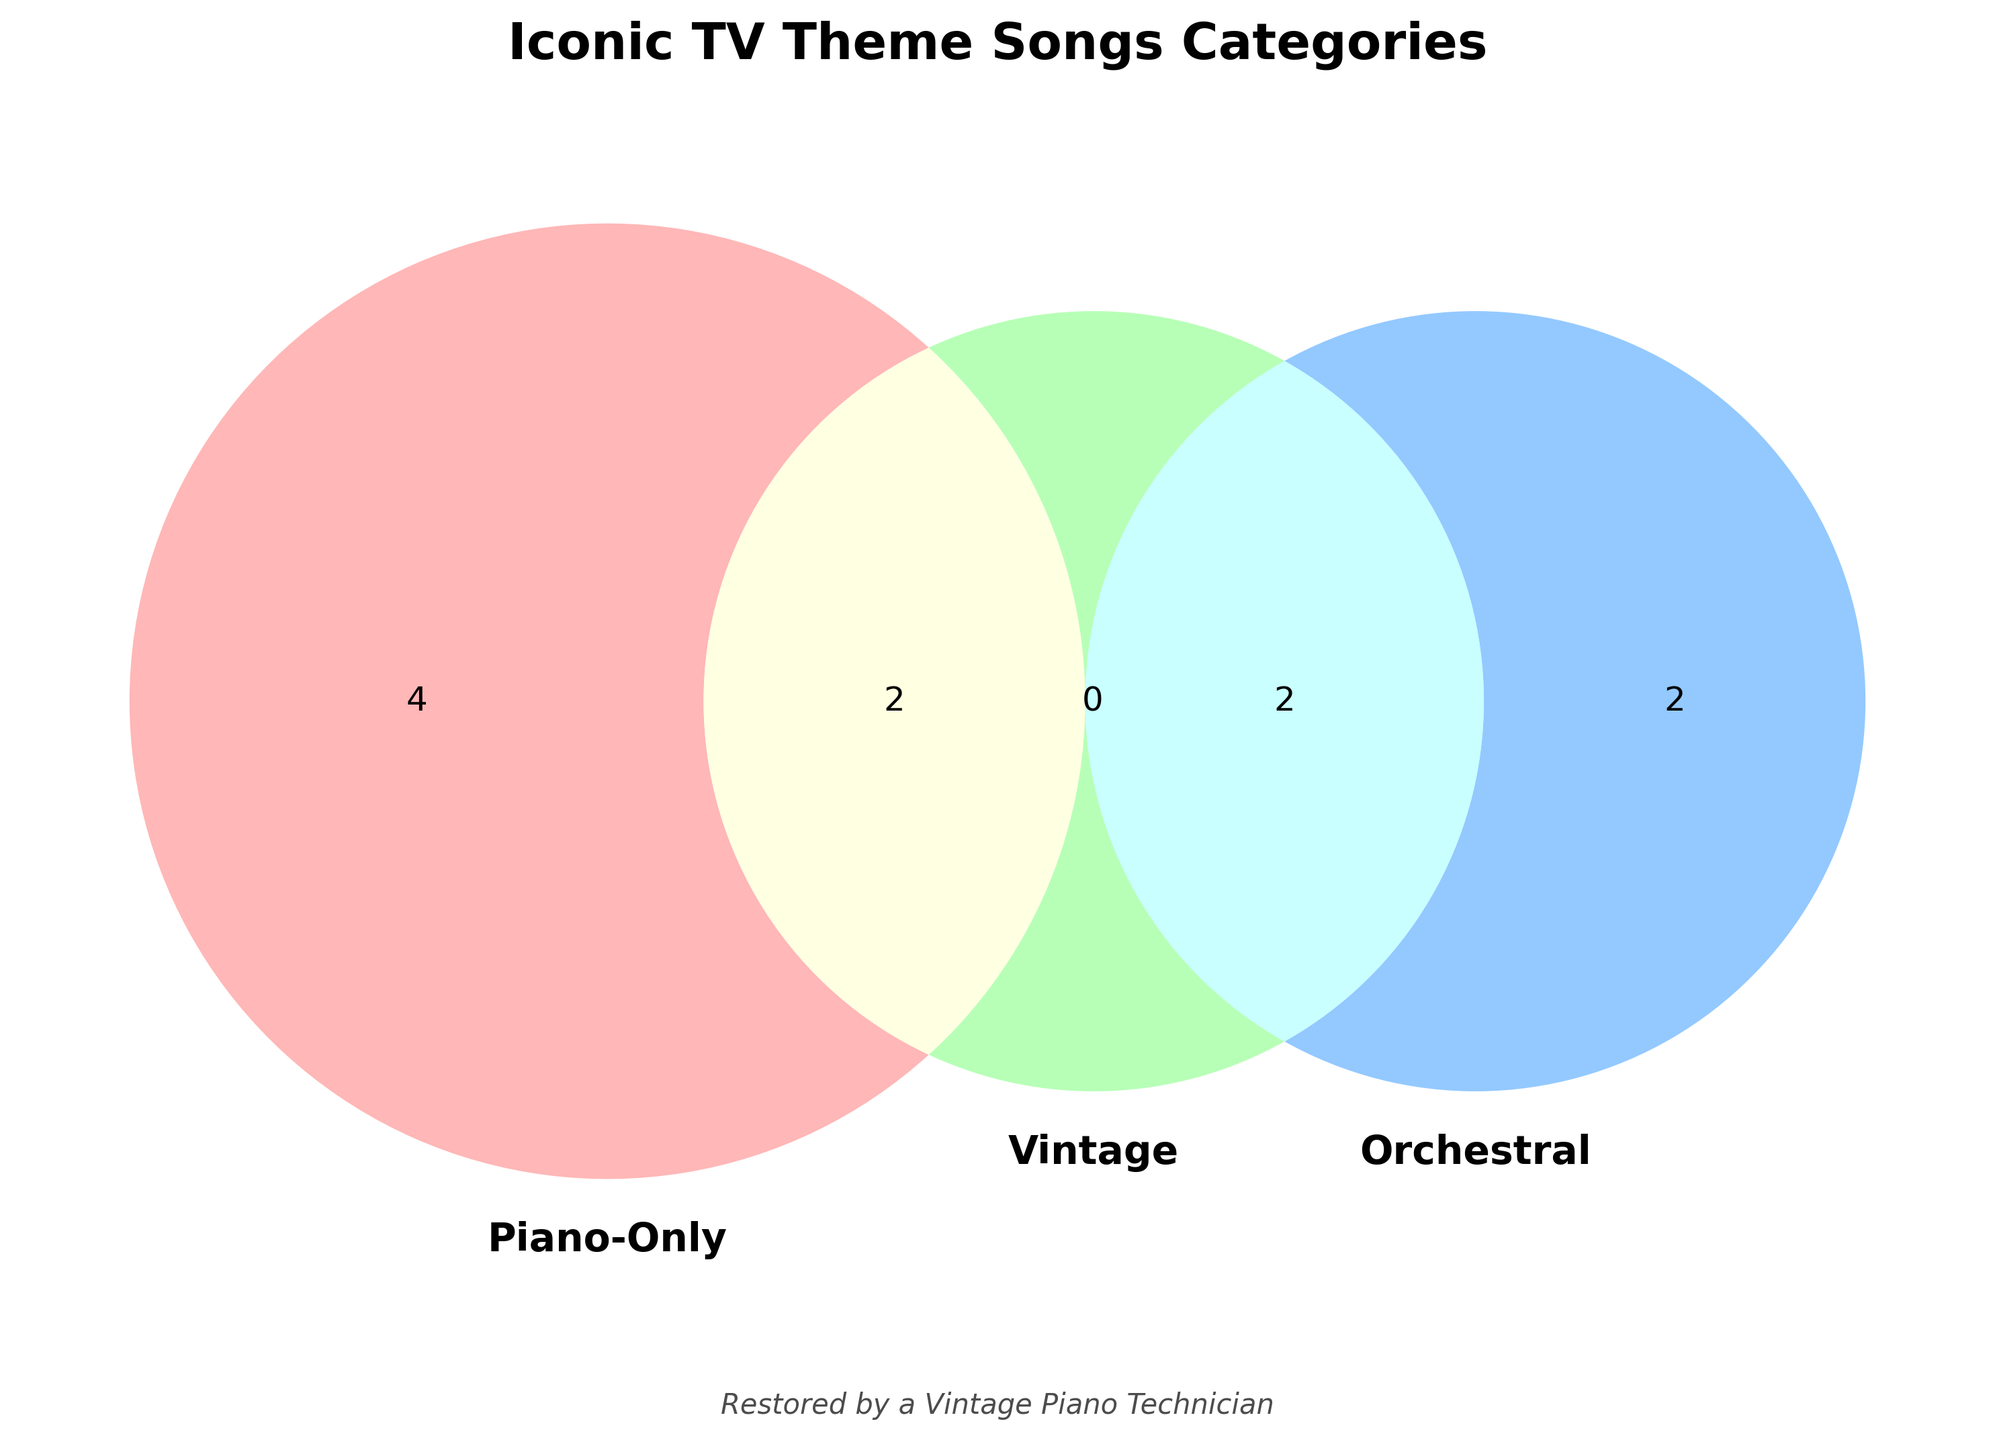What colors are used to represent the three sets? The three sets in the Venn Diagram are visually differentiated using distinct colors: light red, light blue, and light green.
Answer: light red, light blue, light green What is the title of the Venn Diagram? The title of the Venn Diagram is displayed prominently at the top center of the figure.
Answer: Iconic TV Theme Songs Categories How many theme songs are Piano-Only and Vintage? To determine how many theme songs are both Piano-Only and Vintage, look for the intersection of the two circles labeled 'Piano-Only' and 'Vintage'.
Answer: 0 Which theme songs are represented in only the 'Vintage' category? Locate the section of the Venn Diagram that corresponds solely to the 'Vintage' category without overlapping other categories.
Answer: The Twilight Zone, M*A*S*H, The Andy Griffith Show, The Addams Family How many theme songs fall into all three categories? Check the central intersection area where all three sets (Piano-Only, Orchestral, and Vintage) overlap.
Answer: 0 Which theme songs are Piano-Only but not Orchestral or Vintage? Identify the segment of the Venn Diagram that represents only the 'Piano-Only' category without any overlaps with the other two categories.
Answer: The Bold and the Beautiful, Hill Street Blues, Moonlighting, Twin Peaks Are there any theme songs that fall into both Orchestral and Vintage categories but not Piano-Only? Examine the intersection between the 'Orchestral' and 'Vintage' circles and ensure it does not overlap with the 'Piano-Only' circle.
Answer: M*A*S*H, The Addams Family Which category contains the most theme songs? Count the unique theme songs in each category and identify the set with the highest value.
Answer: Piano-Only How many theme songs are Orchestral regardless of whether they are Piano-Only or Vintage? Aggregate the total number of theme songs within the 'Orchestral' set, including overlaps with other sets.
Answer: 4 Is there a theme song that is Piano-Only and Orchestral but not Vintage? Look at the intersection between 'Piano-Only' and 'Orchestral' excluding the 'Vintage' area.
Answer: No 